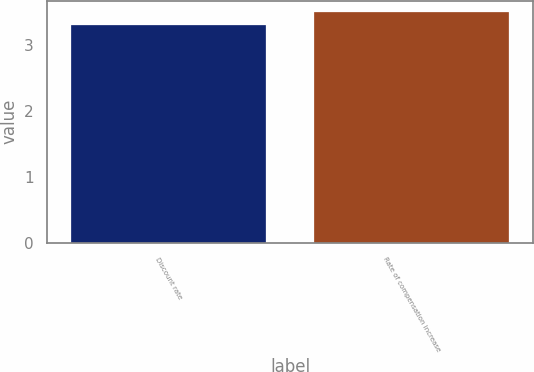Convert chart to OTSL. <chart><loc_0><loc_0><loc_500><loc_500><bar_chart><fcel>Discount rate<fcel>Rate of compensation increase<nl><fcel>3.3<fcel>3.5<nl></chart> 